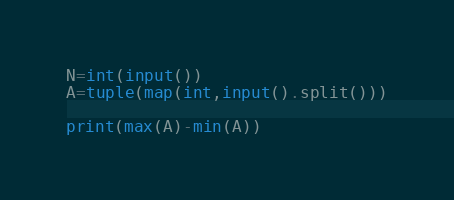Convert code to text. <code><loc_0><loc_0><loc_500><loc_500><_Python_>N=int(input())
A=tuple(map(int,input().split()))

print(max(A)-min(A))</code> 